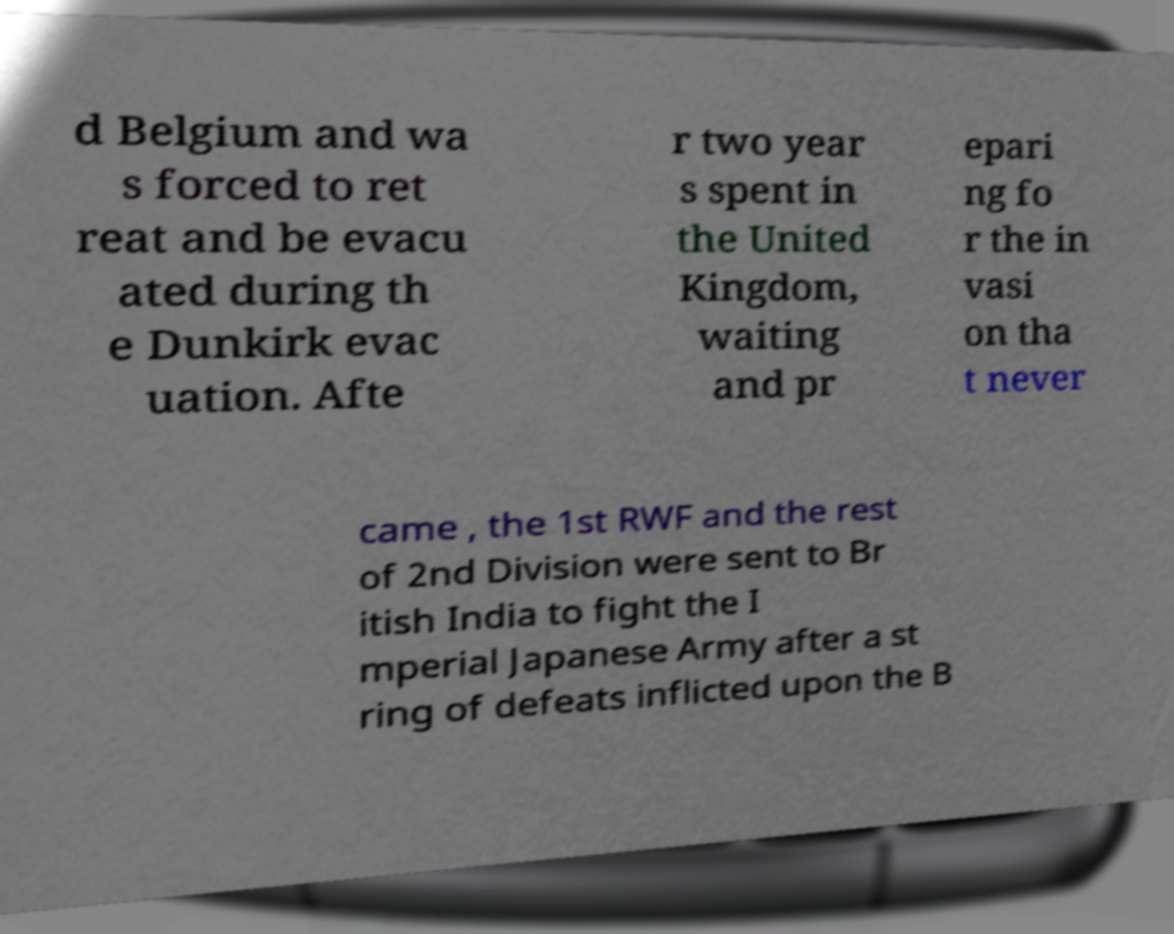What messages or text are displayed in this image? I need them in a readable, typed format. d Belgium and wa s forced to ret reat and be evacu ated during th e Dunkirk evac uation. Afte r two year s spent in the United Kingdom, waiting and pr epari ng fo r the in vasi on tha t never came , the 1st RWF and the rest of 2nd Division were sent to Br itish India to fight the I mperial Japanese Army after a st ring of defeats inflicted upon the B 